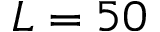<formula> <loc_0><loc_0><loc_500><loc_500>L = 5 0</formula> 